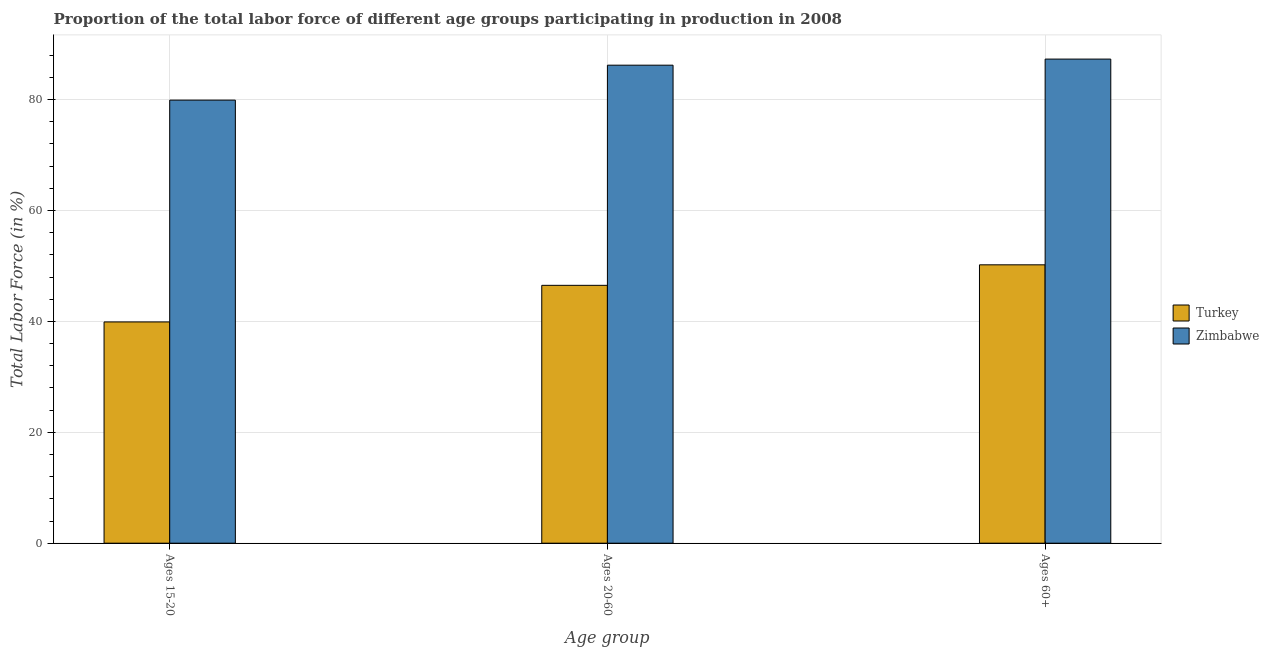How many different coloured bars are there?
Keep it short and to the point. 2. How many groups of bars are there?
Your answer should be very brief. 3. Are the number of bars per tick equal to the number of legend labels?
Ensure brevity in your answer.  Yes. What is the label of the 2nd group of bars from the left?
Keep it short and to the point. Ages 20-60. What is the percentage of labor force within the age group 20-60 in Zimbabwe?
Your answer should be very brief. 86.2. Across all countries, what is the maximum percentage of labor force above age 60?
Offer a terse response. 87.3. Across all countries, what is the minimum percentage of labor force within the age group 15-20?
Provide a short and direct response. 39.9. In which country was the percentage of labor force within the age group 20-60 maximum?
Provide a succinct answer. Zimbabwe. In which country was the percentage of labor force within the age group 20-60 minimum?
Your answer should be very brief. Turkey. What is the total percentage of labor force above age 60 in the graph?
Make the answer very short. 137.5. What is the difference between the percentage of labor force within the age group 15-20 in Turkey and that in Zimbabwe?
Offer a terse response. -40. What is the difference between the percentage of labor force within the age group 15-20 in Turkey and the percentage of labor force within the age group 20-60 in Zimbabwe?
Your answer should be very brief. -46.3. What is the average percentage of labor force above age 60 per country?
Ensure brevity in your answer.  68.75. What is the difference between the percentage of labor force above age 60 and percentage of labor force within the age group 15-20 in Turkey?
Ensure brevity in your answer.  10.3. In how many countries, is the percentage of labor force within the age group 20-60 greater than 56 %?
Offer a terse response. 1. What is the ratio of the percentage of labor force within the age group 15-20 in Zimbabwe to that in Turkey?
Give a very brief answer. 2. Is the difference between the percentage of labor force within the age group 15-20 in Zimbabwe and Turkey greater than the difference between the percentage of labor force above age 60 in Zimbabwe and Turkey?
Your response must be concise. Yes. What is the difference between the highest and the second highest percentage of labor force within the age group 15-20?
Provide a short and direct response. 40. What is the difference between the highest and the lowest percentage of labor force within the age group 20-60?
Your answer should be very brief. 39.7. In how many countries, is the percentage of labor force above age 60 greater than the average percentage of labor force above age 60 taken over all countries?
Keep it short and to the point. 1. Is the sum of the percentage of labor force within the age group 15-20 in Zimbabwe and Turkey greater than the maximum percentage of labor force above age 60 across all countries?
Your response must be concise. Yes. What does the 2nd bar from the left in Ages 20-60 represents?
Ensure brevity in your answer.  Zimbabwe. What does the 2nd bar from the right in Ages 60+ represents?
Ensure brevity in your answer.  Turkey. How many bars are there?
Ensure brevity in your answer.  6. Are all the bars in the graph horizontal?
Your answer should be very brief. No. Are the values on the major ticks of Y-axis written in scientific E-notation?
Give a very brief answer. No. What is the title of the graph?
Offer a very short reply. Proportion of the total labor force of different age groups participating in production in 2008. What is the label or title of the X-axis?
Offer a very short reply. Age group. What is the label or title of the Y-axis?
Make the answer very short. Total Labor Force (in %). What is the Total Labor Force (in %) of Turkey in Ages 15-20?
Give a very brief answer. 39.9. What is the Total Labor Force (in %) of Zimbabwe in Ages 15-20?
Offer a very short reply. 79.9. What is the Total Labor Force (in %) in Turkey in Ages 20-60?
Offer a terse response. 46.5. What is the Total Labor Force (in %) in Zimbabwe in Ages 20-60?
Provide a succinct answer. 86.2. What is the Total Labor Force (in %) of Turkey in Ages 60+?
Your answer should be very brief. 50.2. What is the Total Labor Force (in %) of Zimbabwe in Ages 60+?
Your answer should be very brief. 87.3. Across all Age group, what is the maximum Total Labor Force (in %) in Turkey?
Provide a succinct answer. 50.2. Across all Age group, what is the maximum Total Labor Force (in %) in Zimbabwe?
Your response must be concise. 87.3. Across all Age group, what is the minimum Total Labor Force (in %) in Turkey?
Keep it short and to the point. 39.9. Across all Age group, what is the minimum Total Labor Force (in %) of Zimbabwe?
Ensure brevity in your answer.  79.9. What is the total Total Labor Force (in %) in Turkey in the graph?
Make the answer very short. 136.6. What is the total Total Labor Force (in %) of Zimbabwe in the graph?
Give a very brief answer. 253.4. What is the difference between the Total Labor Force (in %) of Zimbabwe in Ages 15-20 and that in Ages 20-60?
Offer a very short reply. -6.3. What is the difference between the Total Labor Force (in %) of Zimbabwe in Ages 15-20 and that in Ages 60+?
Ensure brevity in your answer.  -7.4. What is the difference between the Total Labor Force (in %) of Turkey in Ages 15-20 and the Total Labor Force (in %) of Zimbabwe in Ages 20-60?
Provide a succinct answer. -46.3. What is the difference between the Total Labor Force (in %) in Turkey in Ages 15-20 and the Total Labor Force (in %) in Zimbabwe in Ages 60+?
Make the answer very short. -47.4. What is the difference between the Total Labor Force (in %) of Turkey in Ages 20-60 and the Total Labor Force (in %) of Zimbabwe in Ages 60+?
Your response must be concise. -40.8. What is the average Total Labor Force (in %) of Turkey per Age group?
Provide a short and direct response. 45.53. What is the average Total Labor Force (in %) of Zimbabwe per Age group?
Offer a terse response. 84.47. What is the difference between the Total Labor Force (in %) of Turkey and Total Labor Force (in %) of Zimbabwe in Ages 15-20?
Your answer should be very brief. -40. What is the difference between the Total Labor Force (in %) in Turkey and Total Labor Force (in %) in Zimbabwe in Ages 20-60?
Your answer should be compact. -39.7. What is the difference between the Total Labor Force (in %) in Turkey and Total Labor Force (in %) in Zimbabwe in Ages 60+?
Make the answer very short. -37.1. What is the ratio of the Total Labor Force (in %) of Turkey in Ages 15-20 to that in Ages 20-60?
Offer a terse response. 0.86. What is the ratio of the Total Labor Force (in %) of Zimbabwe in Ages 15-20 to that in Ages 20-60?
Offer a terse response. 0.93. What is the ratio of the Total Labor Force (in %) in Turkey in Ages 15-20 to that in Ages 60+?
Your response must be concise. 0.79. What is the ratio of the Total Labor Force (in %) of Zimbabwe in Ages 15-20 to that in Ages 60+?
Make the answer very short. 0.92. What is the ratio of the Total Labor Force (in %) in Turkey in Ages 20-60 to that in Ages 60+?
Your response must be concise. 0.93. What is the ratio of the Total Labor Force (in %) in Zimbabwe in Ages 20-60 to that in Ages 60+?
Provide a short and direct response. 0.99. What is the difference between the highest and the second highest Total Labor Force (in %) in Turkey?
Offer a terse response. 3.7. What is the difference between the highest and the lowest Total Labor Force (in %) in Turkey?
Provide a succinct answer. 10.3. What is the difference between the highest and the lowest Total Labor Force (in %) in Zimbabwe?
Provide a succinct answer. 7.4. 